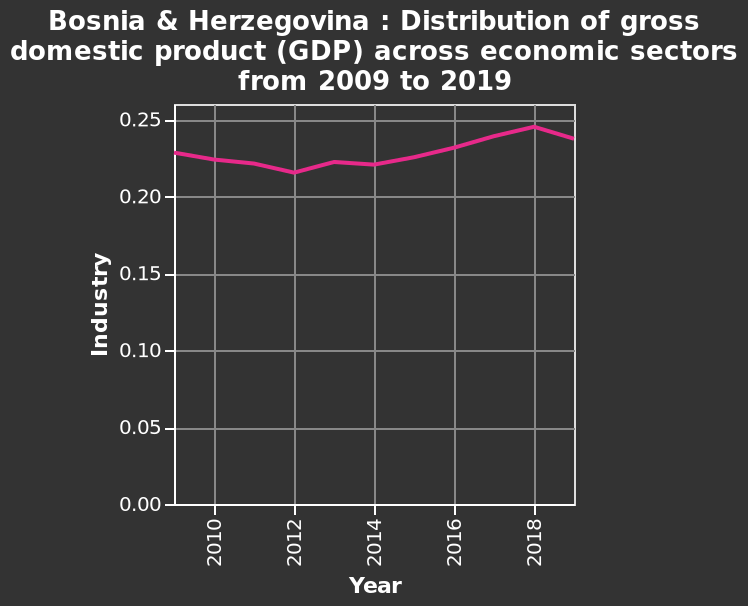<image>
What was the reported GDP distribution in Bosnia and Herzegovina in 2020?  The reported GDP distribution in Bosnia and Herzegovina in 2020 was 0.24. 